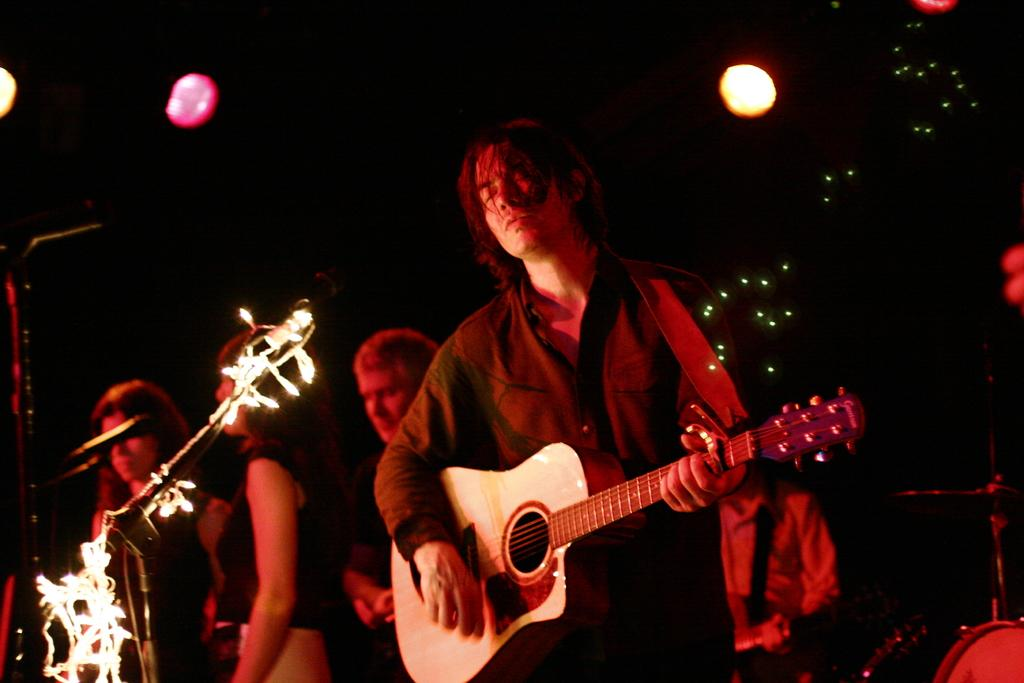What is the man in the image doing? The man is playing a guitar in the image. What can be seen in the background or surrounding the man? There are lights visible in the image. How many birds are sitting on the slope in the image? There are no birds or slopes present in the image; it features a man playing a guitar with lights visible. 